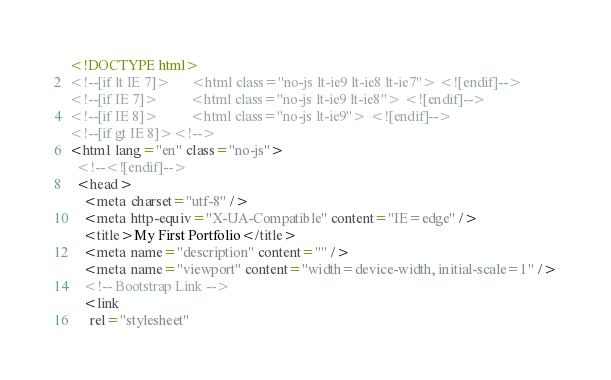<code> <loc_0><loc_0><loc_500><loc_500><_HTML_><!DOCTYPE html>
<!--[if lt IE 7]>      <html class="no-js lt-ie9 lt-ie8 lt-ie7"> <![endif]-->
<!--[if IE 7]>         <html class="no-js lt-ie9 lt-ie8"> <![endif]-->
<!--[if IE 8]>         <html class="no-js lt-ie9"> <![endif]-->
<!--[if gt IE 8]><!-->
<html lang="en" class="no-js">
  <!--<![endif]-->
  <head>
    <meta charset="utf-8" />
    <meta http-equiv="X-UA-Compatible" content="IE=edge" />
    <title>My First Portfolio</title>
    <meta name="description" content="" />
    <meta name="viewport" content="width=device-width, initial-scale=1" />
    <!-- Bootstrap Link -->
    <link
      rel="stylesheet"</code> 